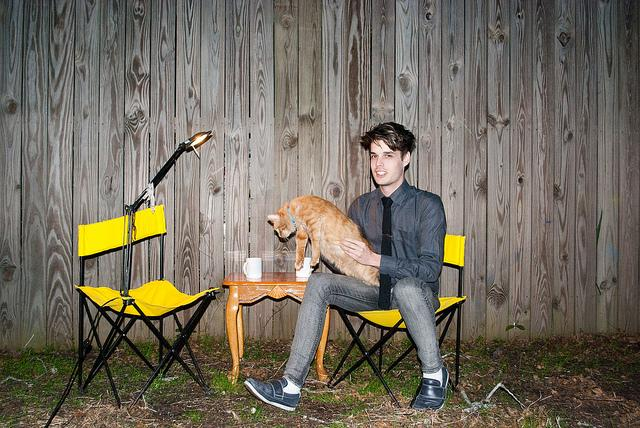What is the breed of this cat? Please explain your reasoning. ragdoll. The cat is striped and orange. it is very close to a tabby cat. 